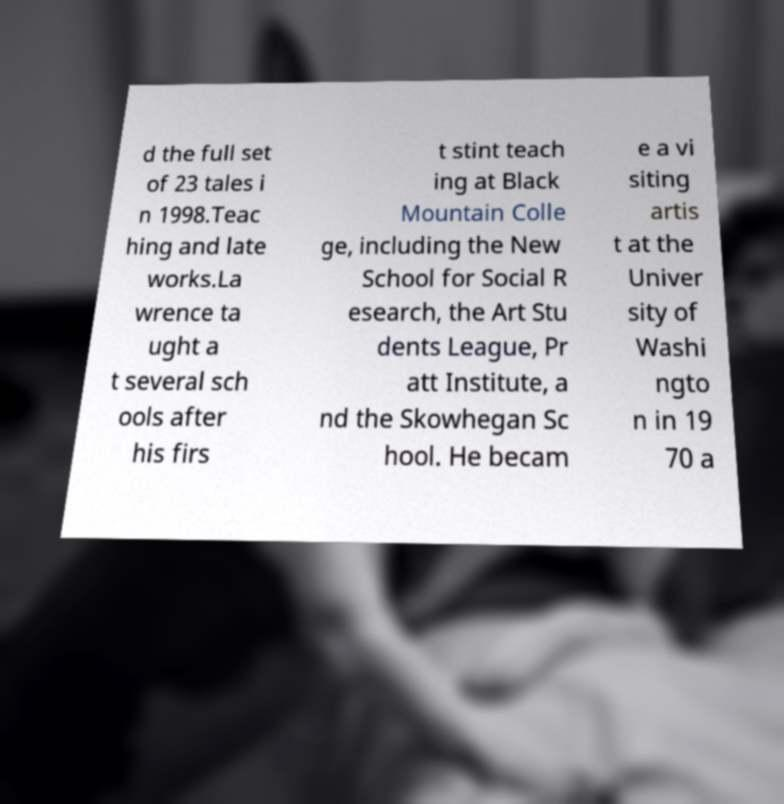I need the written content from this picture converted into text. Can you do that? d the full set of 23 tales i n 1998.Teac hing and late works.La wrence ta ught a t several sch ools after his firs t stint teach ing at Black Mountain Colle ge, including the New School for Social R esearch, the Art Stu dents League, Pr att Institute, a nd the Skowhegan Sc hool. He becam e a vi siting artis t at the Univer sity of Washi ngto n in 19 70 a 